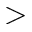<formula> <loc_0><loc_0><loc_500><loc_500>></formula> 